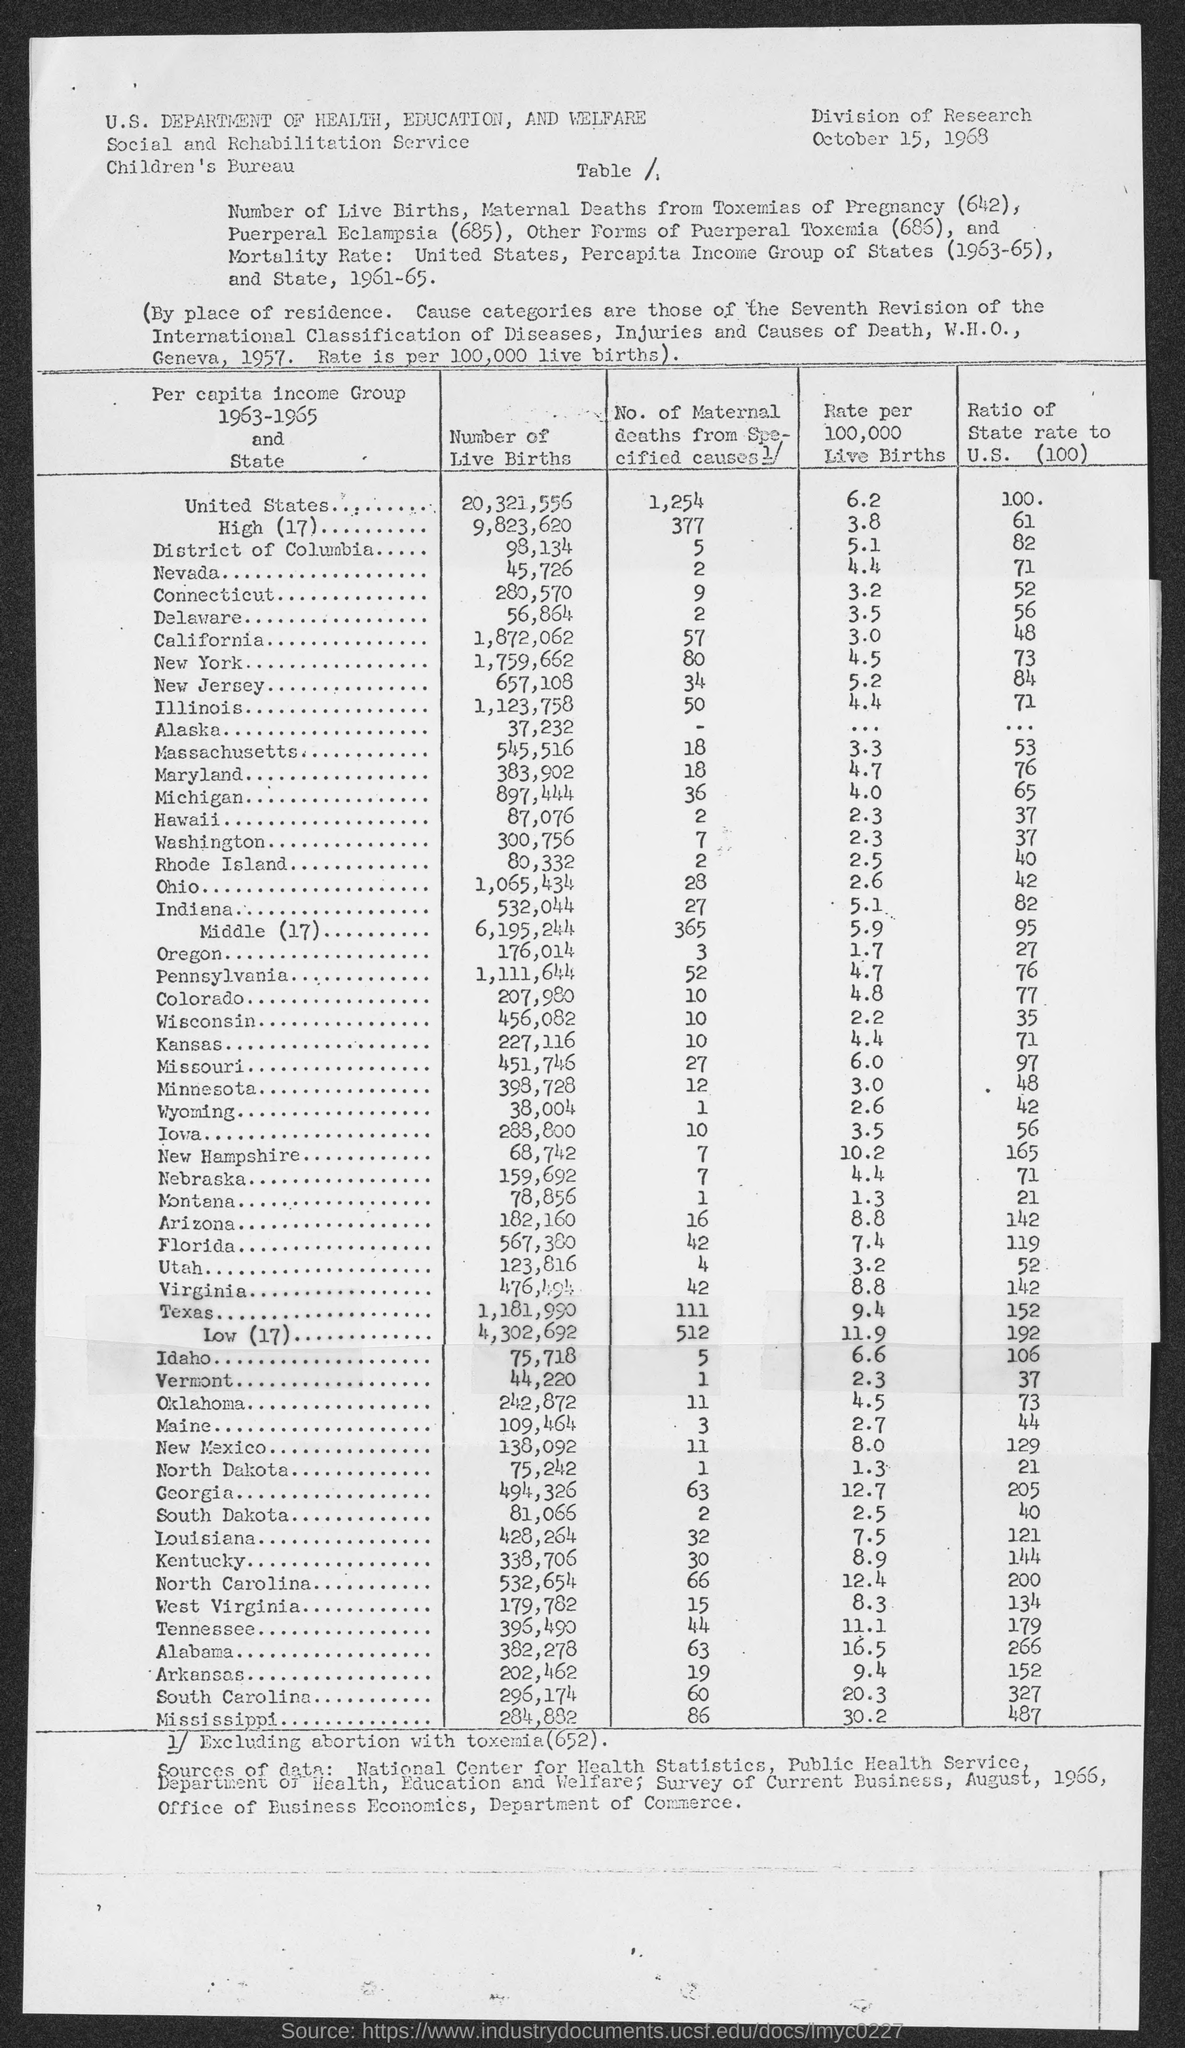Mention a couple of crucial points in this snapshot. The ratio of the state rate to the U.S. in Delaware is 56. The ratio of the state rate to the U.S. in Maryland is 76%. The ratio of the state rate to the U.S. (100) in Illinois is 71%. In the District of Columbia, the state rate is 82% of the U.S. rate. In Connecticut, the ratio of the State rate to the U.S. rate is 52%. 